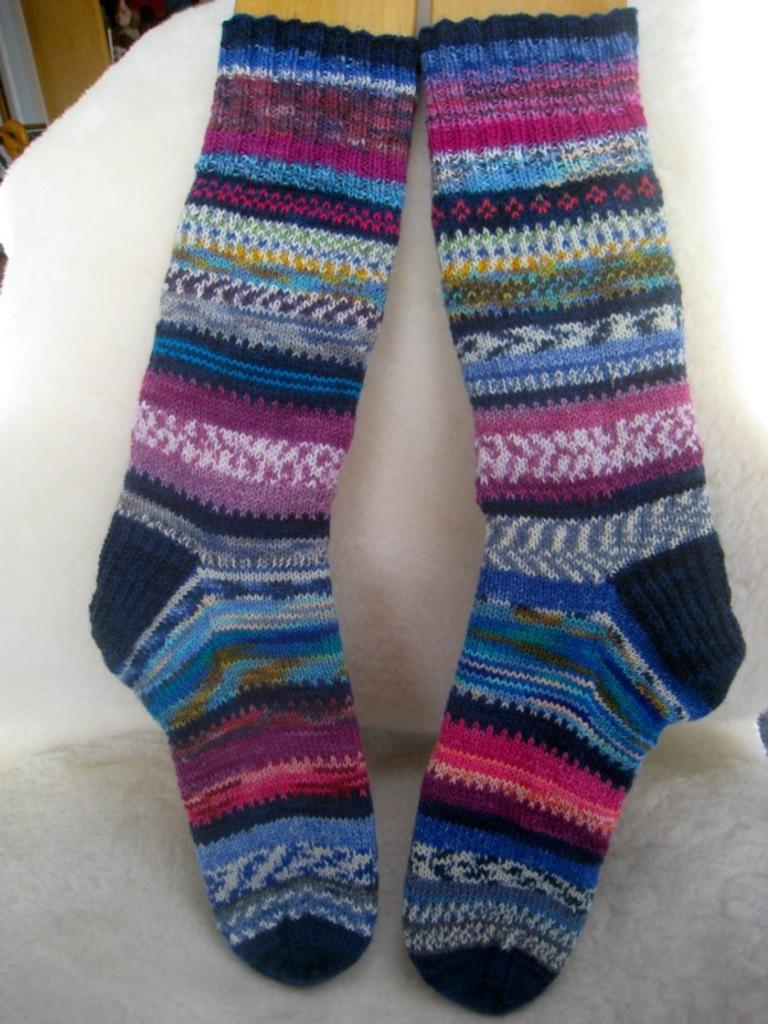What type of clothing item is present in the image? There is a pair of socks in the image. Where are the socks located? The socks are on a chair. What type of work is the sock teaching in the image? There is no indication of any work or teaching in the image; it simply shows a pair of socks on a chair. 